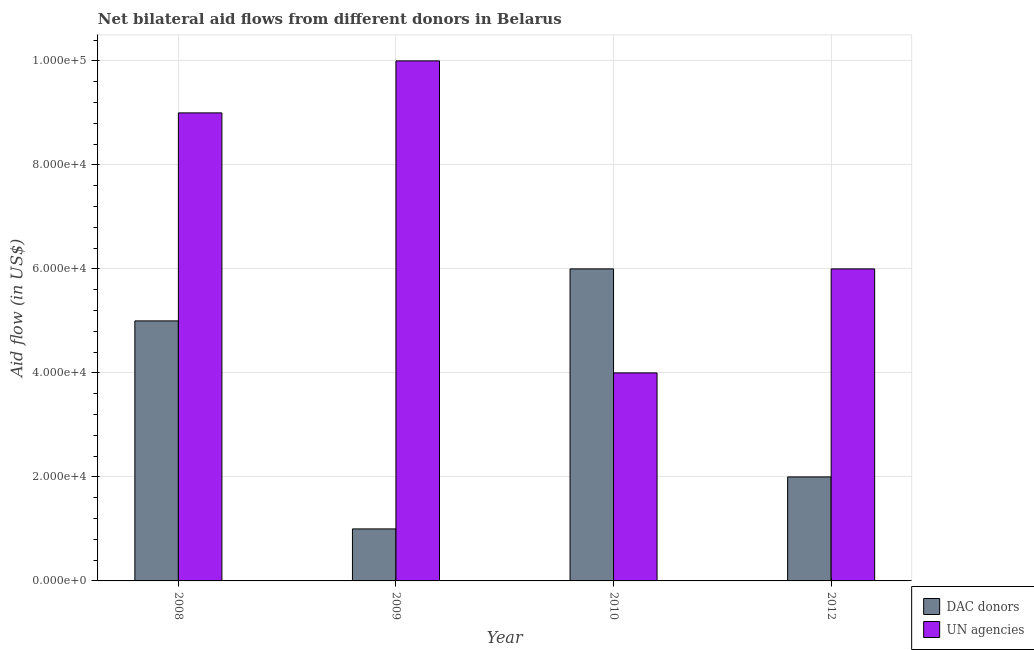How many different coloured bars are there?
Offer a terse response. 2. How many groups of bars are there?
Make the answer very short. 4. Are the number of bars per tick equal to the number of legend labels?
Provide a short and direct response. Yes. Are the number of bars on each tick of the X-axis equal?
Keep it short and to the point. Yes. How many bars are there on the 3rd tick from the left?
Your response must be concise. 2. What is the aid flow from un agencies in 2008?
Your response must be concise. 9.00e+04. Across all years, what is the maximum aid flow from un agencies?
Keep it short and to the point. 1.00e+05. Across all years, what is the minimum aid flow from dac donors?
Ensure brevity in your answer.  10000. What is the total aid flow from un agencies in the graph?
Provide a short and direct response. 2.90e+05. What is the difference between the aid flow from dac donors in 2008 and that in 2009?
Your answer should be compact. 4.00e+04. What is the difference between the aid flow from dac donors in 2008 and the aid flow from un agencies in 2010?
Provide a succinct answer. -10000. What is the average aid flow from un agencies per year?
Ensure brevity in your answer.  7.25e+04. In how many years, is the aid flow from un agencies greater than 88000 US$?
Provide a succinct answer. 2. Is the aid flow from un agencies in 2008 less than that in 2012?
Provide a succinct answer. No. What is the difference between the highest and the lowest aid flow from un agencies?
Offer a terse response. 6.00e+04. In how many years, is the aid flow from dac donors greater than the average aid flow from dac donors taken over all years?
Offer a terse response. 2. What does the 2nd bar from the left in 2012 represents?
Provide a succinct answer. UN agencies. What does the 1st bar from the right in 2010 represents?
Ensure brevity in your answer.  UN agencies. Are all the bars in the graph horizontal?
Offer a very short reply. No. What is the difference between two consecutive major ticks on the Y-axis?
Ensure brevity in your answer.  2.00e+04. Where does the legend appear in the graph?
Ensure brevity in your answer.  Bottom right. How are the legend labels stacked?
Give a very brief answer. Vertical. What is the title of the graph?
Give a very brief answer. Net bilateral aid flows from different donors in Belarus. What is the label or title of the Y-axis?
Offer a very short reply. Aid flow (in US$). What is the Aid flow (in US$) in UN agencies in 2008?
Give a very brief answer. 9.00e+04. What is the Aid flow (in US$) of DAC donors in 2010?
Make the answer very short. 6.00e+04. What is the Aid flow (in US$) of UN agencies in 2010?
Give a very brief answer. 4.00e+04. What is the Aid flow (in US$) in DAC donors in 2012?
Your answer should be very brief. 2.00e+04. Across all years, what is the maximum Aid flow (in US$) of DAC donors?
Your response must be concise. 6.00e+04. Across all years, what is the minimum Aid flow (in US$) of UN agencies?
Your answer should be compact. 4.00e+04. What is the total Aid flow (in US$) of UN agencies in the graph?
Provide a short and direct response. 2.90e+05. What is the difference between the Aid flow (in US$) in UN agencies in 2009 and that in 2010?
Offer a terse response. 6.00e+04. What is the difference between the Aid flow (in US$) of DAC donors in 2009 and that in 2012?
Give a very brief answer. -10000. What is the difference between the Aid flow (in US$) in UN agencies in 2009 and that in 2012?
Keep it short and to the point. 4.00e+04. What is the difference between the Aid flow (in US$) in DAC donors in 2010 and that in 2012?
Keep it short and to the point. 4.00e+04. What is the difference between the Aid flow (in US$) in UN agencies in 2010 and that in 2012?
Offer a terse response. -2.00e+04. What is the difference between the Aid flow (in US$) in DAC donors in 2008 and the Aid flow (in US$) in UN agencies in 2009?
Offer a terse response. -5.00e+04. What is the difference between the Aid flow (in US$) of DAC donors in 2008 and the Aid flow (in US$) of UN agencies in 2010?
Provide a succinct answer. 10000. What is the difference between the Aid flow (in US$) of DAC donors in 2009 and the Aid flow (in US$) of UN agencies in 2012?
Your answer should be compact. -5.00e+04. What is the average Aid flow (in US$) in DAC donors per year?
Offer a terse response. 3.50e+04. What is the average Aid flow (in US$) in UN agencies per year?
Offer a terse response. 7.25e+04. In the year 2008, what is the difference between the Aid flow (in US$) in DAC donors and Aid flow (in US$) in UN agencies?
Make the answer very short. -4.00e+04. In the year 2012, what is the difference between the Aid flow (in US$) of DAC donors and Aid flow (in US$) of UN agencies?
Offer a very short reply. -4.00e+04. What is the ratio of the Aid flow (in US$) in DAC donors in 2008 to that in 2009?
Your response must be concise. 5. What is the ratio of the Aid flow (in US$) of UN agencies in 2008 to that in 2009?
Provide a short and direct response. 0.9. What is the ratio of the Aid flow (in US$) in UN agencies in 2008 to that in 2010?
Give a very brief answer. 2.25. What is the ratio of the Aid flow (in US$) in DAC donors in 2009 to that in 2010?
Offer a very short reply. 0.17. What is the ratio of the Aid flow (in US$) in UN agencies in 2009 to that in 2010?
Make the answer very short. 2.5. What is the ratio of the Aid flow (in US$) in DAC donors in 2009 to that in 2012?
Offer a terse response. 0.5. What is the difference between the highest and the second highest Aid flow (in US$) in DAC donors?
Provide a succinct answer. 10000. What is the difference between the highest and the lowest Aid flow (in US$) of DAC donors?
Your answer should be compact. 5.00e+04. What is the difference between the highest and the lowest Aid flow (in US$) in UN agencies?
Give a very brief answer. 6.00e+04. 